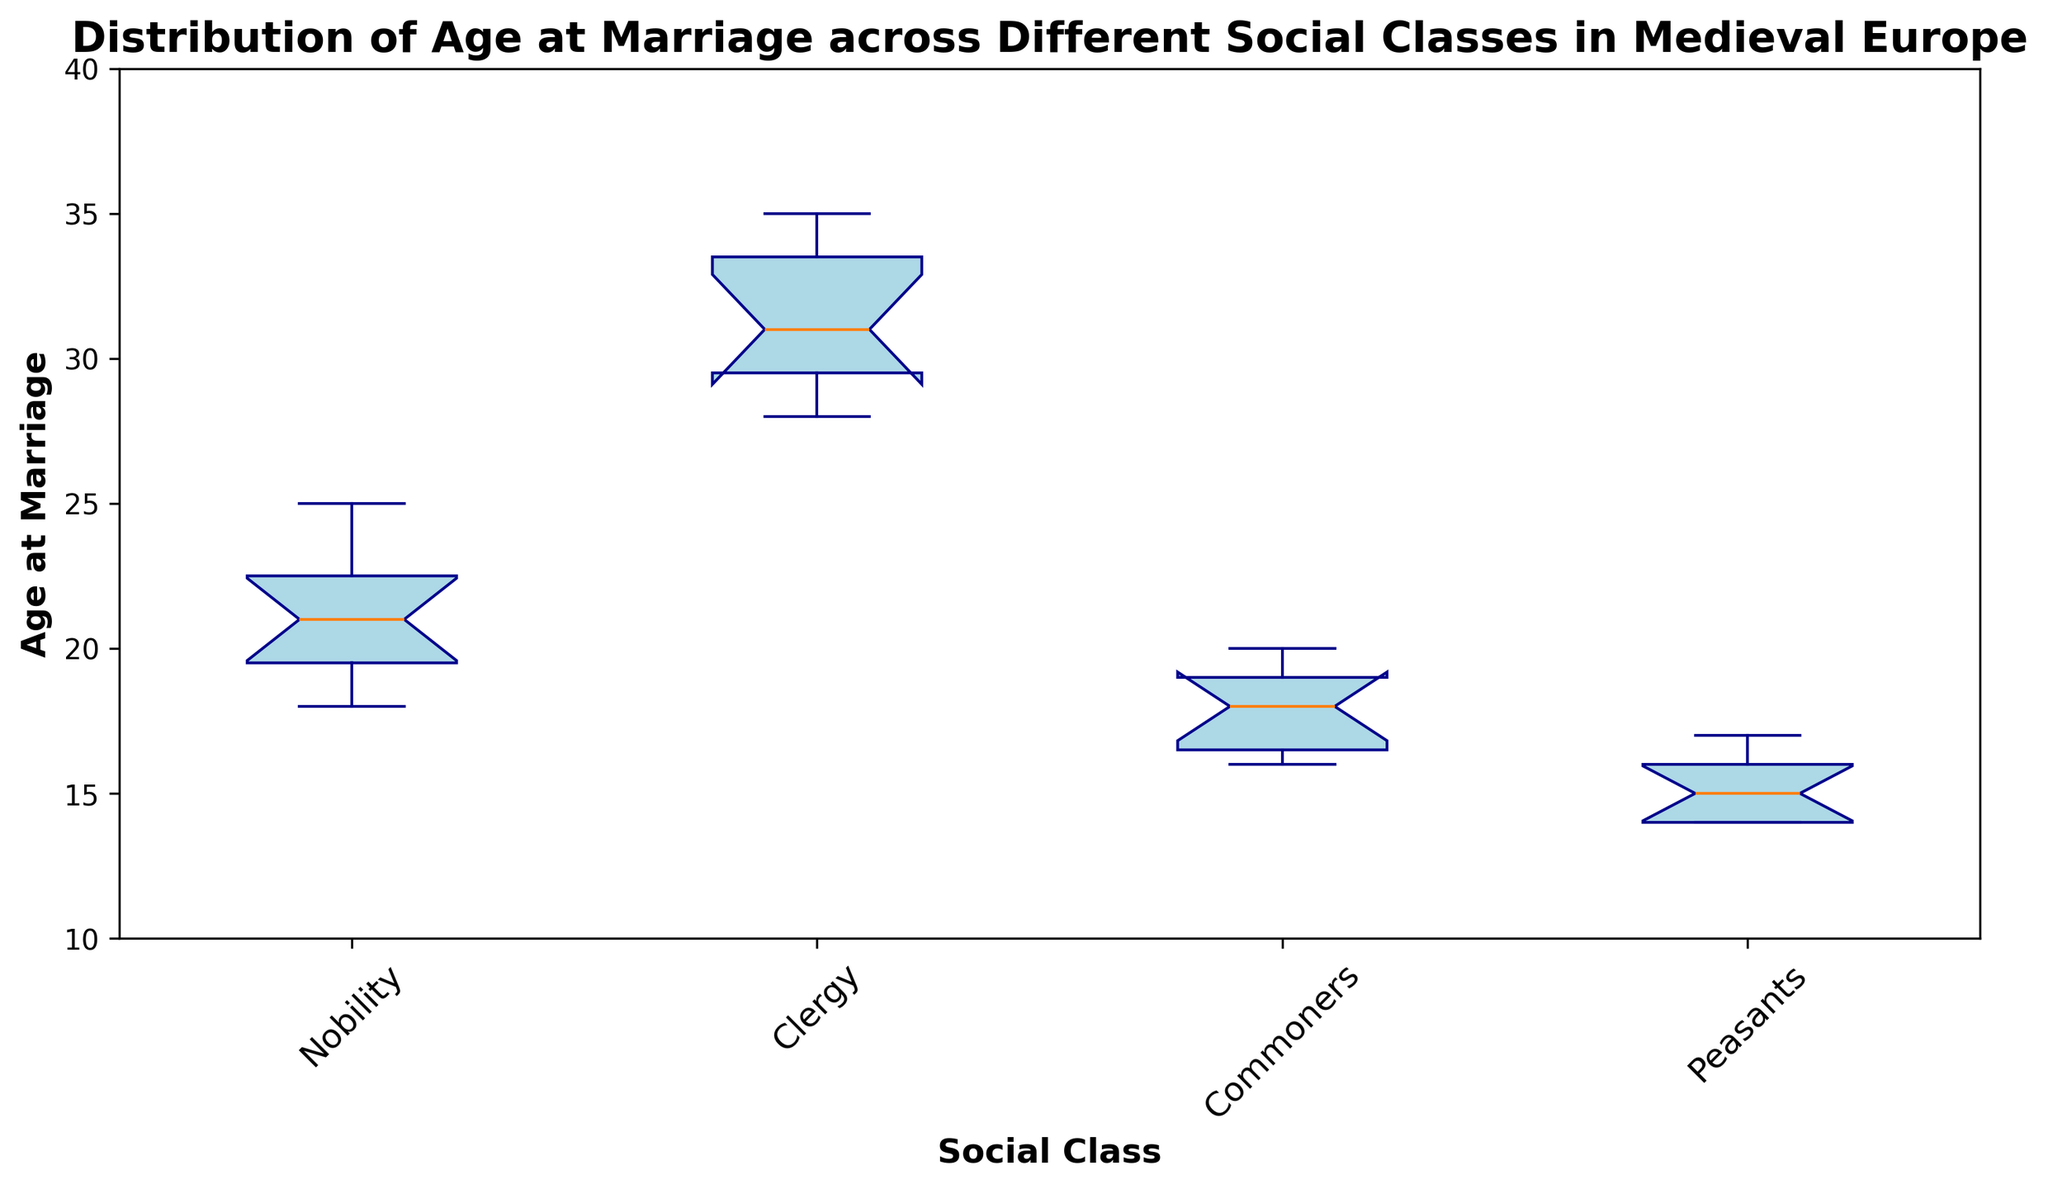Which social class shows the widest range of age at marriage? To determine the widest range, we observe the extent of the whiskers (ends of the vertical lines) in the boxplot. The Clergy class has the widest range with a span from around 28 to 35.
Answer: Clergy What is the median age at marriage for Nobility? To find the median, look at the line inside the box of the Nobility class. The median age is represented by this line, which is at 21.
Answer: 21 Which social class has the lowest median age at marriage? By comparing the lines inside the boxes of all classes, the Peasants class has the lowest median line, which appears to be around 15.
Answer: Peasants How does the median age at marriage for Commoners compare to Clergy? Compare the lines within the boxes. The Commoners class has a median around 18, while the Clergy class has a median around 31.Thus, the median age for Clergy is higher than that for Commoners.
Answer: Clergy's median is higher What is the interquartile range (IQR) for the Nobility class? The IQR is the difference between the third quartile (top edge of the box) and the first quartile (bottom edge of the box). For Nobility, the top edge is around 23 and the bottom edge around 19, so the IQR is 23 - 19 = 4.
Answer: 4 Which social class has the smallest interquartile range (IQR)? By examining the differences between the top and bottom edges of boxes, the Peasants class has the smallest IQR with its box edges being closely set around 14 and 16, an IQR of 2 units.
Answer: Peasants Which social class has the oldest maximum age at marriage? The top whisker of the box represents the maximum value. The Clergy class has the highest top whisker, indicating the oldest maximum age, which is around 35.
Answer: Clergy How do the outliers in the Nobility class compare to other classes? Outliers are represented by red circles outside the whiskers. The Nobility class has no outliers, while other classes like Clergy and Peasants also show no outliers in this plot.
Answer: No outliers What is the age difference between the oldest average ages of Clergy and Peasants classes? The Clergy's median age (center line of the Clergy's box) is around 31, and the Peasants' median age is 15. The difference is 31 - 15 = 16.
Answer: 16 Which social class has the highest median age at marriage? Compare the lines inside the boxes of all classes. The Clergy class has the highest median, around 31.
Answer: Clergy 